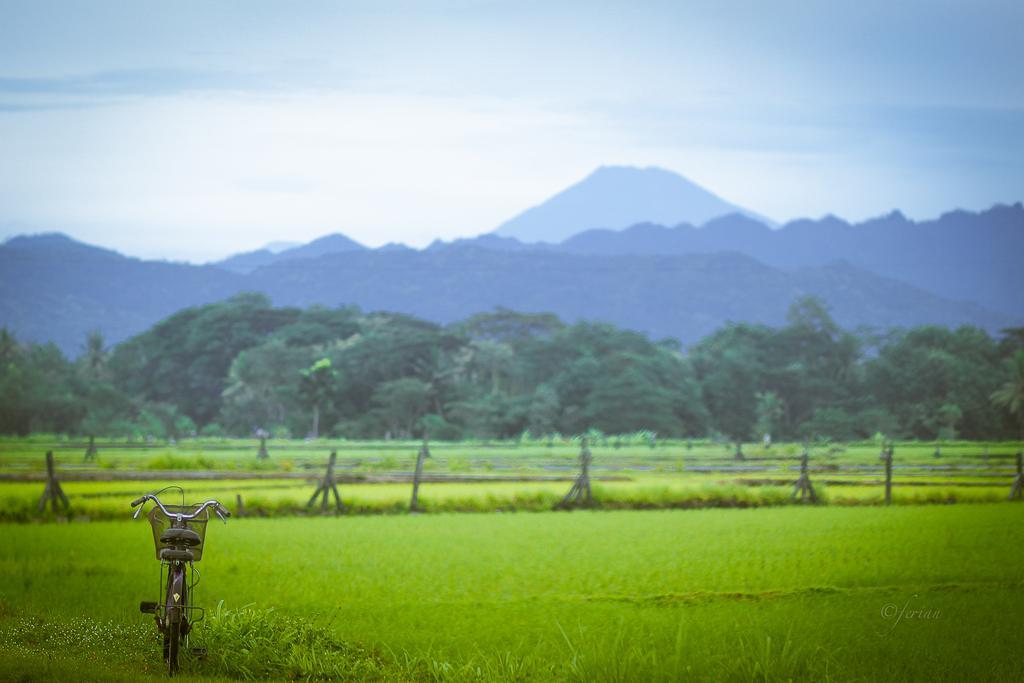Could you give a brief overview of what you see in this image? In this picture there is a bicycle at the bottom side of the image and there is greenery in the image. 